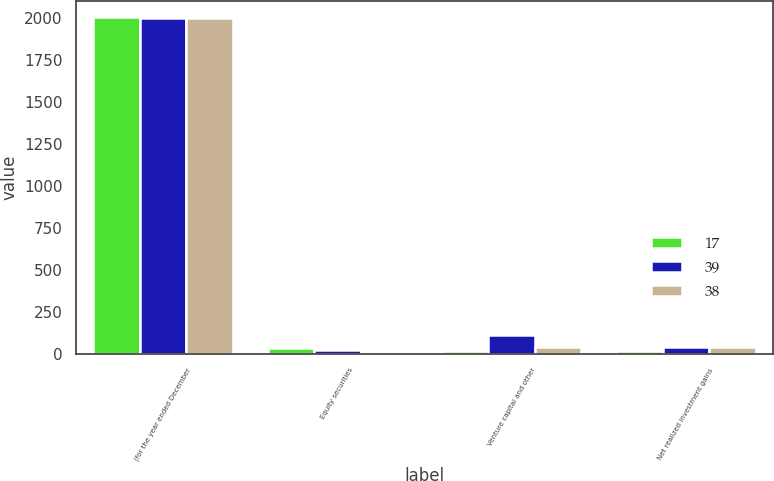<chart> <loc_0><loc_0><loc_500><loc_500><stacked_bar_chart><ecel><fcel>(for the year ended December<fcel>Equity securities<fcel>Venture capital and other<fcel>Net realized investment gains<nl><fcel>17<fcel>2005<fcel>34<fcel>17<fcel>17<nl><fcel>39<fcel>2004<fcel>23<fcel>113<fcel>39<nl><fcel>38<fcel>2003<fcel>7<fcel>38<fcel>38<nl></chart> 